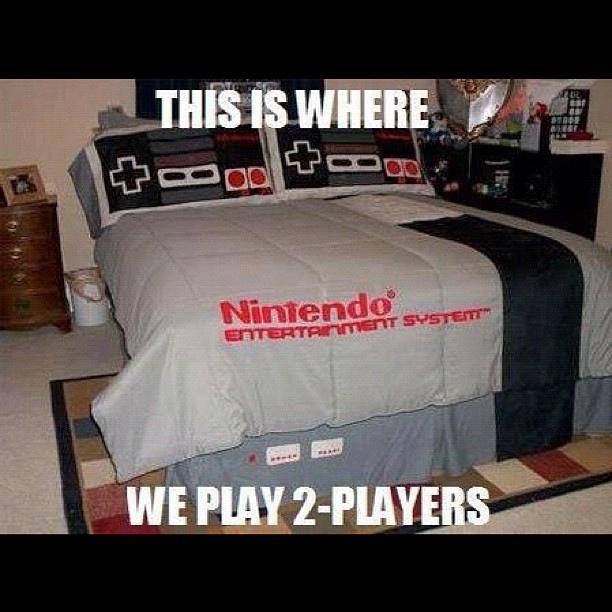Why is this bedsheet popular?
Answer briefly. Nintendo. What colors are the letters SUP?
Keep it brief. Red. Company name on the bedspread?
Concise answer only. Nintendo. What size mattress is this?
Short answer required. Queen. Is the bed neat?
Answer briefly. Yes. 